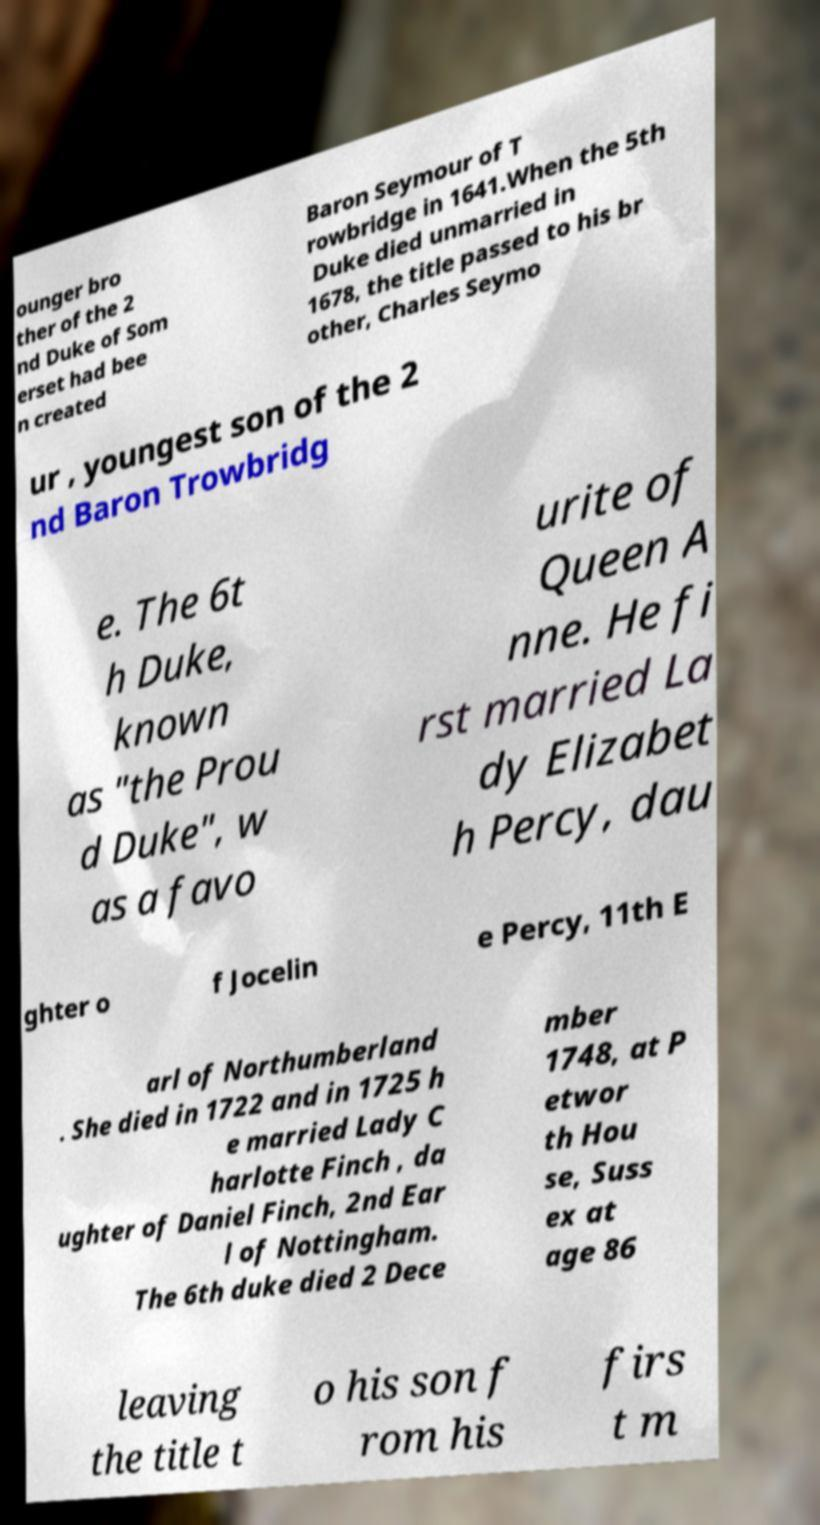Please identify and transcribe the text found in this image. ounger bro ther of the 2 nd Duke of Som erset had bee n created Baron Seymour of T rowbridge in 1641.When the 5th Duke died unmarried in 1678, the title passed to his br other, Charles Seymo ur , youngest son of the 2 nd Baron Trowbridg e. The 6t h Duke, known as "the Prou d Duke", w as a favo urite of Queen A nne. He fi rst married La dy Elizabet h Percy, dau ghter o f Jocelin e Percy, 11th E arl of Northumberland . She died in 1722 and in 1725 h e married Lady C harlotte Finch , da ughter of Daniel Finch, 2nd Ear l of Nottingham. The 6th duke died 2 Dece mber 1748, at P etwor th Hou se, Suss ex at age 86 leaving the title t o his son f rom his firs t m 